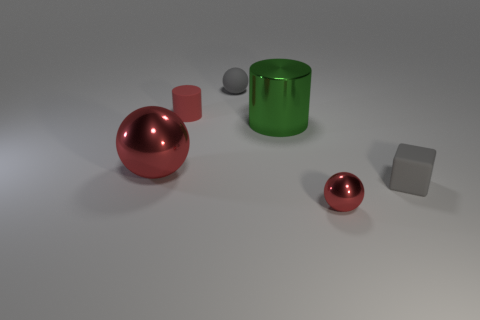Subtract all shiny spheres. How many spheres are left? 1 Subtract all gray spheres. How many spheres are left? 2 Add 1 green metal objects. How many objects exist? 7 Subtract all cylinders. How many objects are left? 4 Subtract 1 balls. How many balls are left? 2 Subtract all large balls. Subtract all big shiny objects. How many objects are left? 3 Add 4 small red rubber objects. How many small red rubber objects are left? 5 Add 5 green shiny balls. How many green shiny balls exist? 5 Subtract 0 purple blocks. How many objects are left? 6 Subtract all brown cylinders. Subtract all yellow spheres. How many cylinders are left? 2 